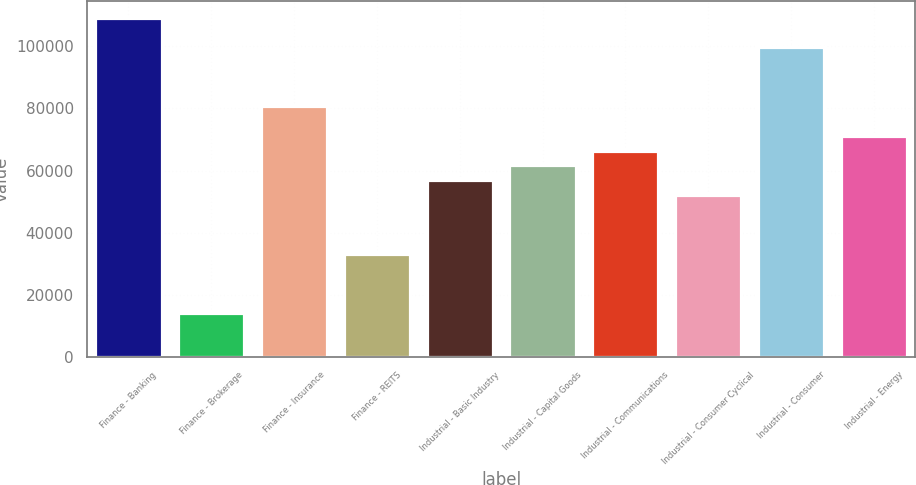<chart> <loc_0><loc_0><loc_500><loc_500><bar_chart><fcel>Finance - Banking<fcel>Finance - Brokerage<fcel>Finance - Insurance<fcel>Finance - REITS<fcel>Industrial - Basic Industry<fcel>Industrial - Capital Goods<fcel>Industrial - Communications<fcel>Industrial - Consumer Cyclical<fcel>Industrial - Consumer<fcel>Industrial - Energy<nl><fcel>109050<fcel>14293.9<fcel>80622.9<fcel>33245<fcel>56934<fcel>61671.8<fcel>66409.6<fcel>52196.2<fcel>99574.1<fcel>71147.4<nl></chart> 